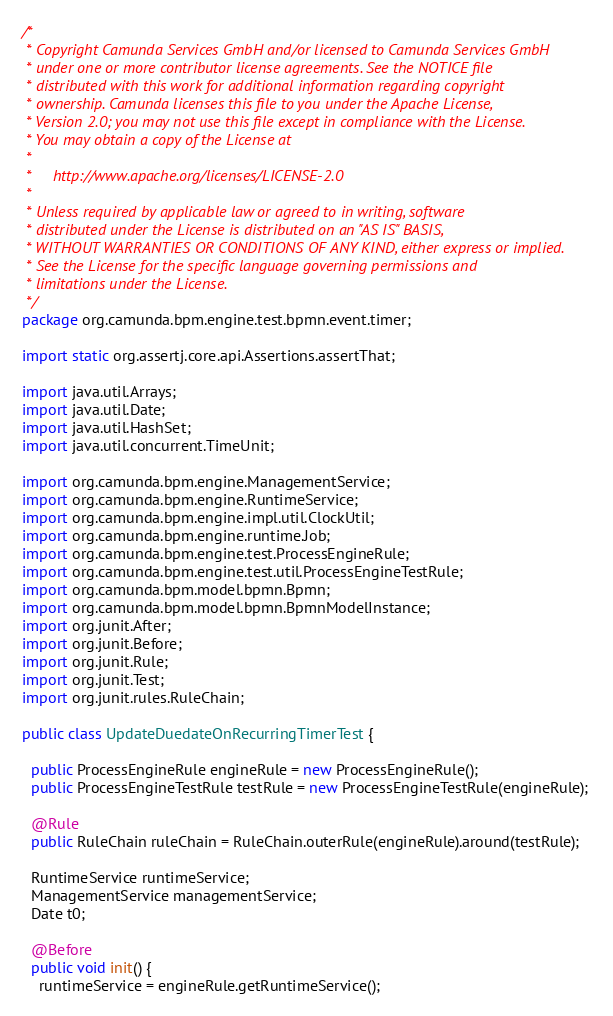Convert code to text. <code><loc_0><loc_0><loc_500><loc_500><_Java_>/*
 * Copyright Camunda Services GmbH and/or licensed to Camunda Services GmbH
 * under one or more contributor license agreements. See the NOTICE file
 * distributed with this work for additional information regarding copyright
 * ownership. Camunda licenses this file to you under the Apache License,
 * Version 2.0; you may not use this file except in compliance with the License.
 * You may obtain a copy of the License at
 *
 *     http://www.apache.org/licenses/LICENSE-2.0
 *
 * Unless required by applicable law or agreed to in writing, software
 * distributed under the License is distributed on an "AS IS" BASIS,
 * WITHOUT WARRANTIES OR CONDITIONS OF ANY KIND, either express or implied.
 * See the License for the specific language governing permissions and
 * limitations under the License.
 */
package org.camunda.bpm.engine.test.bpmn.event.timer;

import static org.assertj.core.api.Assertions.assertThat;

import java.util.Arrays;
import java.util.Date;
import java.util.HashSet;
import java.util.concurrent.TimeUnit;

import org.camunda.bpm.engine.ManagementService;
import org.camunda.bpm.engine.RuntimeService;
import org.camunda.bpm.engine.impl.util.ClockUtil;
import org.camunda.bpm.engine.runtime.Job;
import org.camunda.bpm.engine.test.ProcessEngineRule;
import org.camunda.bpm.engine.test.util.ProcessEngineTestRule;
import org.camunda.bpm.model.bpmn.Bpmn;
import org.camunda.bpm.model.bpmn.BpmnModelInstance;
import org.junit.After;
import org.junit.Before;
import org.junit.Rule;
import org.junit.Test;
import org.junit.rules.RuleChain;

public class UpdateDuedateOnRecurringTimerTest {

  public ProcessEngineRule engineRule = new ProcessEngineRule();
  public ProcessEngineTestRule testRule = new ProcessEngineTestRule(engineRule);

  @Rule
  public RuleChain ruleChain = RuleChain.outerRule(engineRule).around(testRule);

  RuntimeService runtimeService;
  ManagementService managementService;
  Date t0;

  @Before
  public void init() {
    runtimeService = engineRule.getRuntimeService();</code> 